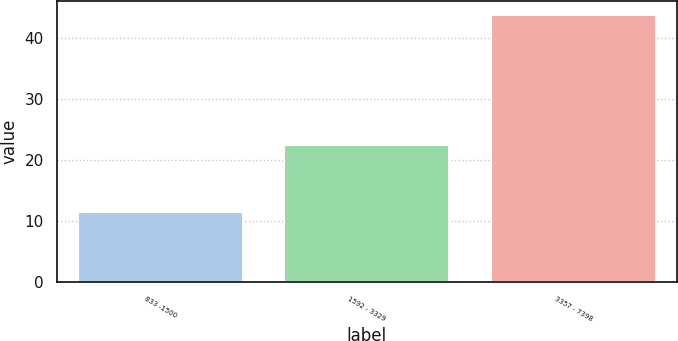Convert chart. <chart><loc_0><loc_0><loc_500><loc_500><bar_chart><fcel>833 -1500<fcel>1592 - 3329<fcel>3357 - 7398<nl><fcel>11.42<fcel>22.45<fcel>43.89<nl></chart> 